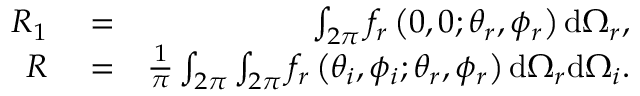<formula> <loc_0><loc_0><loc_500><loc_500>\begin{array} { r l r } { R _ { 1 } } & = } & { \int _ { 2 \pi } f _ { r } \left ( 0 , 0 ; \theta _ { r } , \phi _ { r } \right ) d \Omega _ { r } , } \\ { R } & = } & { \frac { 1 } { \pi } \int _ { 2 \pi } \int _ { 2 \pi } f _ { r } \left ( \theta _ { i } , \phi _ { i } ; \theta _ { r } , \phi _ { r } \right ) d \Omega _ { r } d \Omega _ { i } . } \end{array}</formula> 